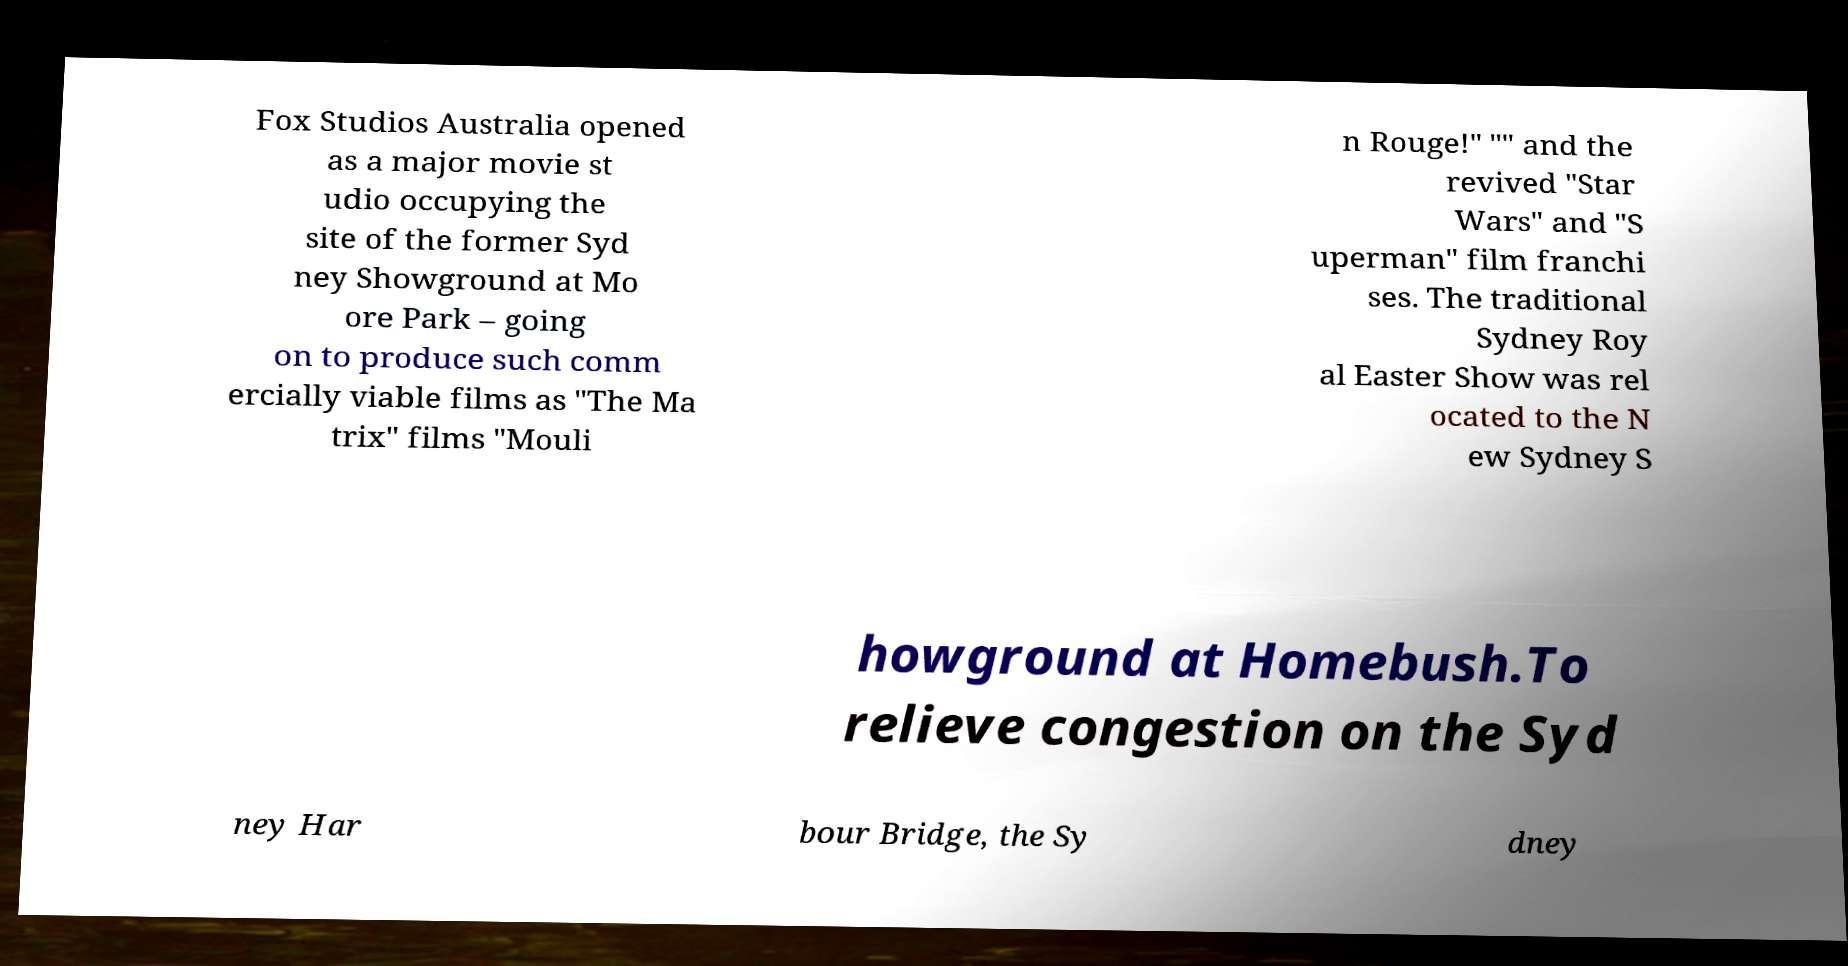I need the written content from this picture converted into text. Can you do that? Fox Studios Australia opened as a major movie st udio occupying the site of the former Syd ney Showground at Mo ore Park – going on to produce such comm ercially viable films as "The Ma trix" films "Mouli n Rouge!" "" and the revived "Star Wars" and "S uperman" film franchi ses. The traditional Sydney Roy al Easter Show was rel ocated to the N ew Sydney S howground at Homebush.To relieve congestion on the Syd ney Har bour Bridge, the Sy dney 